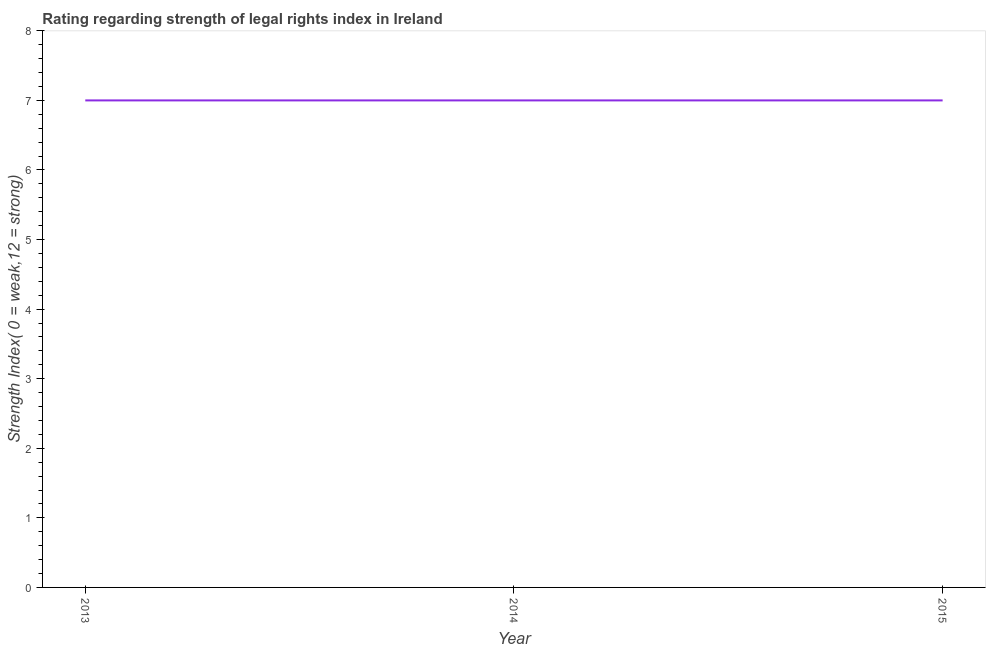What is the strength of legal rights index in 2014?
Provide a succinct answer. 7. Across all years, what is the maximum strength of legal rights index?
Provide a short and direct response. 7. Across all years, what is the minimum strength of legal rights index?
Your response must be concise. 7. What is the sum of the strength of legal rights index?
Your answer should be very brief. 21. What is the difference between the strength of legal rights index in 2014 and 2015?
Your response must be concise. 0. What is the median strength of legal rights index?
Your answer should be compact. 7. In how many years, is the strength of legal rights index greater than 5.6 ?
Offer a very short reply. 3. Do a majority of the years between 2013 and 2014 (inclusive) have strength of legal rights index greater than 3 ?
Your answer should be compact. Yes. What is the ratio of the strength of legal rights index in 2014 to that in 2015?
Make the answer very short. 1. Is the difference between the strength of legal rights index in 2013 and 2015 greater than the difference between any two years?
Your answer should be compact. Yes. What is the difference between the highest and the second highest strength of legal rights index?
Keep it short and to the point. 0. In how many years, is the strength of legal rights index greater than the average strength of legal rights index taken over all years?
Your answer should be compact. 0. Does the strength of legal rights index monotonically increase over the years?
Your answer should be very brief. No. Are the values on the major ticks of Y-axis written in scientific E-notation?
Offer a terse response. No. Does the graph contain any zero values?
Make the answer very short. No. What is the title of the graph?
Ensure brevity in your answer.  Rating regarding strength of legal rights index in Ireland. What is the label or title of the Y-axis?
Your answer should be very brief. Strength Index( 0 = weak,12 = strong). What is the Strength Index( 0 = weak,12 = strong) of 2015?
Keep it short and to the point. 7. What is the ratio of the Strength Index( 0 = weak,12 = strong) in 2013 to that in 2014?
Give a very brief answer. 1. What is the ratio of the Strength Index( 0 = weak,12 = strong) in 2013 to that in 2015?
Ensure brevity in your answer.  1. What is the ratio of the Strength Index( 0 = weak,12 = strong) in 2014 to that in 2015?
Make the answer very short. 1. 